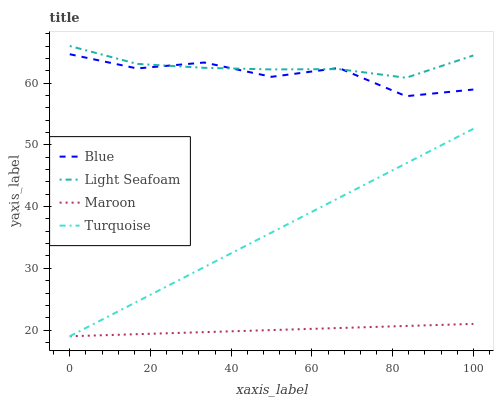Does Turquoise have the minimum area under the curve?
Answer yes or no. No. Does Turquoise have the maximum area under the curve?
Answer yes or no. No. Is Turquoise the smoothest?
Answer yes or no. No. Is Turquoise the roughest?
Answer yes or no. No. Does Light Seafoam have the lowest value?
Answer yes or no. No. Does Turquoise have the highest value?
Answer yes or no. No. Is Turquoise less than Blue?
Answer yes or no. Yes. Is Blue greater than Turquoise?
Answer yes or no. Yes. Does Turquoise intersect Blue?
Answer yes or no. No. 